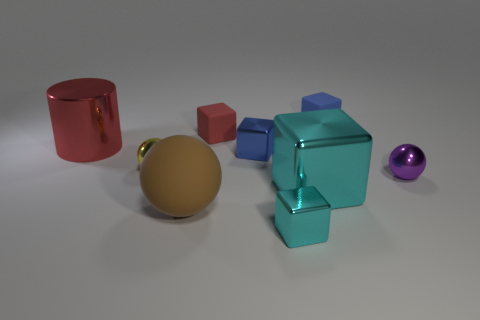Subtract all brown balls. How many balls are left? 2 Subtract 2 spheres. How many spheres are left? 1 Subtract all red cubes. How many cubes are left? 4 Subtract all spheres. How many objects are left? 6 Subtract 0 gray cylinders. How many objects are left? 9 Subtract all brown spheres. Subtract all brown cubes. How many spheres are left? 2 Subtract all cyan cylinders. How many blue cubes are left? 2 Subtract all spheres. Subtract all red matte balls. How many objects are left? 6 Add 4 metal blocks. How many metal blocks are left? 7 Add 7 brown things. How many brown things exist? 8 